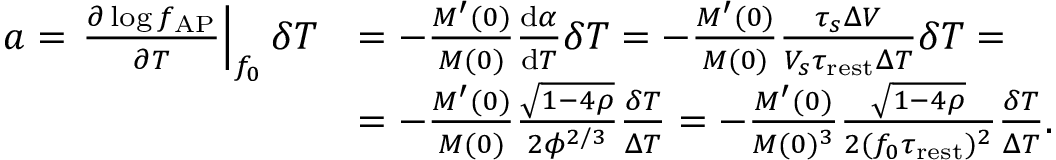<formula> <loc_0><loc_0><loc_500><loc_500>\begin{array} { r l } { a = \frac { \partial \log f _ { A P } } { \partial T } \right | _ { f _ { 0 } } \delta T } & { = - \frac { M ^ { \prime } ( 0 ) } { M ( 0 ) } \frac { d \alpha } { d T } \delta T = - \frac { M ^ { \prime } ( 0 ) } { M ( 0 ) } \frac { \tau _ { s } \Delta V } { V _ { s } \tau _ { r e s t } \Delta T } \delta T = } \\ & { = - \frac { M ^ { \prime } ( 0 ) } { M ( 0 ) } \frac { \sqrt { 1 - 4 \rho } } { 2 \phi ^ { 2 / 3 } } \frac { \delta T } { \Delta T } = - \frac { M ^ { \prime } ( 0 ) } { M ( 0 ) ^ { 3 } } \frac { \sqrt { 1 - 4 \rho } } { 2 ( f _ { 0 } \tau _ { r e s t } ) ^ { 2 } } \frac { \delta T } { \Delta T } . } \end{array}</formula> 